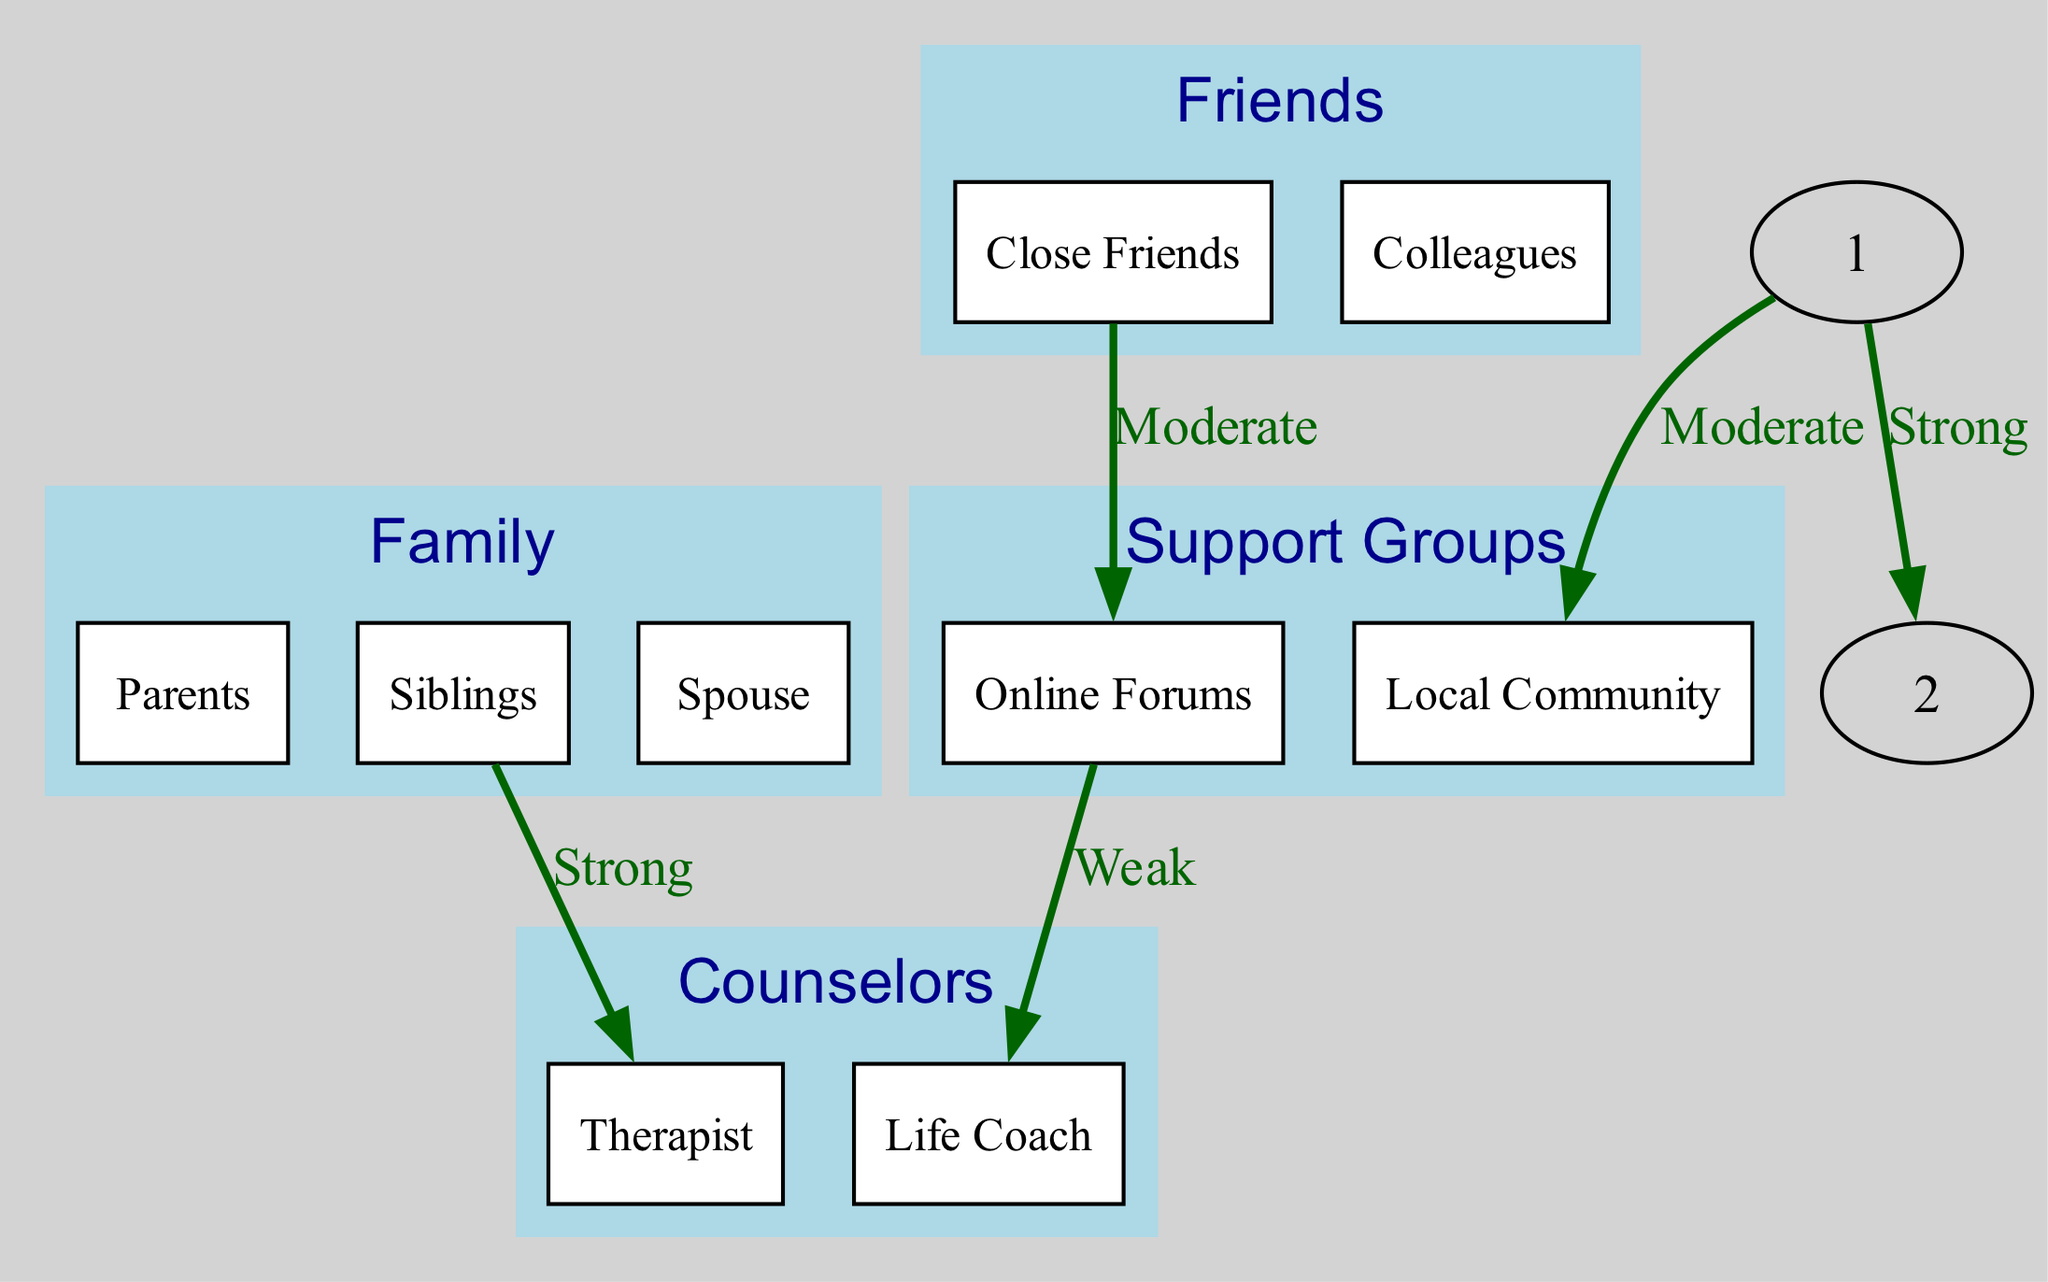What are the main categories of support in the diagram? The diagram shows four main categories: Family, Friends, Support Groups, and Counselors. These categories are represented as nodes at the top level of the diagram.
Answer: Family, Friends, Support Groups, Counselors How many child nodes does the Family category have? The Family category has three child nodes: Parents, Siblings, and Spouse. Counting these nodes gives us a total of three.
Answer: 3 Which group provides support to Close Friends? According to the diagram, Close Friends receive support from the Friends category, which is a direct connection reflected in the edges.
Answer: Friends What is the intensity of support from Siblings to Counselors? The diagram shows no direct connection or edge between Siblings and Counselors, indicating that there is no support intensity measured between them.
Answer: None Which node connects Strongly to the Local Community? The diagram indicates that the Family node connects strongly to the Local Community, labeled as a moderate level of support.
Answer: Family Which individual is connected weakly to the Life Coach? The diagram indicates that the Online Forums node is connected weakly to the Life Coach, as shown by the labeled edge connecting them.
Answer: Online Forums How many edges are there in total in the diagram? By counting the edges listed in the diagram, there are a total of five edges connecting the different nodes, representing various support relationships among them.
Answer: 5 What is the connection type between Siblings and Therapist? The connection between Siblings (child of Family) and Therapist (child of Counselors) is labeled as Strong, indicating significant support from Siblings to Therapist.
Answer: Strong Which category is connected to the most child nodes? The Family category stands out as it has the most child nodes compared to others, with three subcategories (Parents, Siblings, Spouse) detailed in the diagram.
Answer: Family 